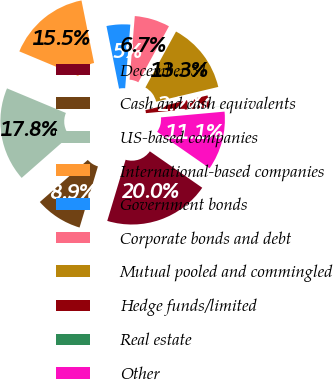Convert chart. <chart><loc_0><loc_0><loc_500><loc_500><pie_chart><fcel>December 31<fcel>Cash and cash equivalents<fcel>US-based companies<fcel>International-based companies<fcel>Government bonds<fcel>Corporate bonds and debt<fcel>Mutual pooled and commingled<fcel>Hedge funds/limited<fcel>Real estate<fcel>Other<nl><fcel>19.98%<fcel>8.89%<fcel>17.76%<fcel>15.54%<fcel>4.46%<fcel>6.67%<fcel>13.33%<fcel>2.24%<fcel>0.02%<fcel>11.11%<nl></chart> 